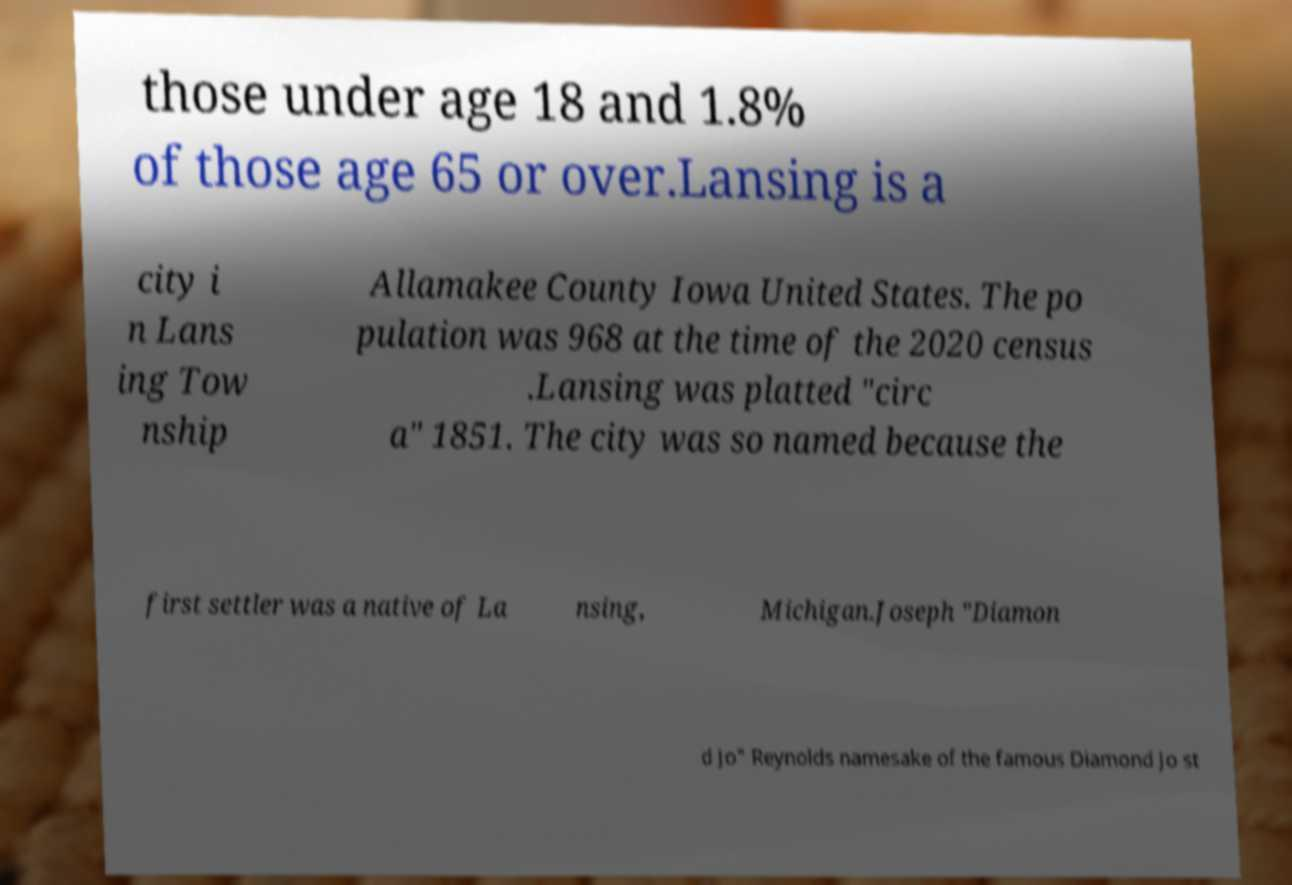Could you extract and type out the text from this image? those under age 18 and 1.8% of those age 65 or over.Lansing is a city i n Lans ing Tow nship Allamakee County Iowa United States. The po pulation was 968 at the time of the 2020 census .Lansing was platted "circ a" 1851. The city was so named because the first settler was a native of La nsing, Michigan.Joseph "Diamon d Jo" Reynolds namesake of the famous Diamond Jo st 